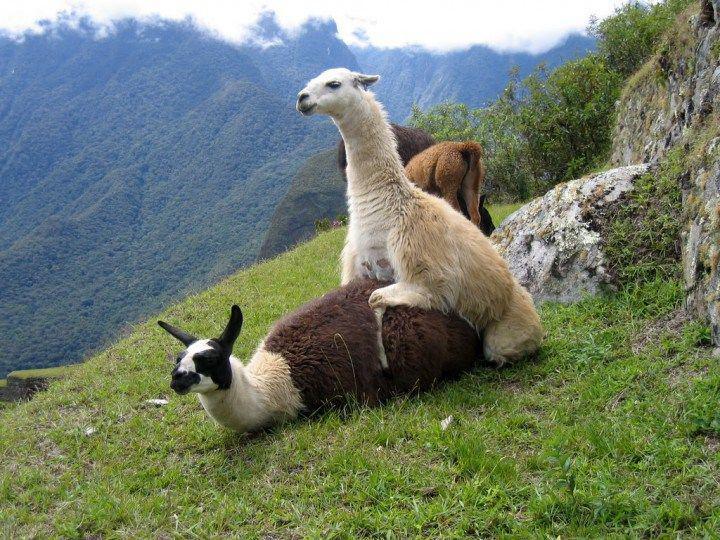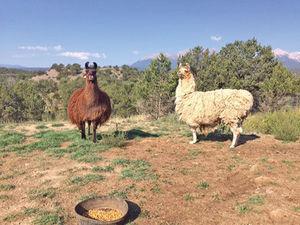The first image is the image on the left, the second image is the image on the right. Evaluate the accuracy of this statement regarding the images: "The llamas in the image on the right are standing with their sides touching.". Is it true? Answer yes or no. No. The first image is the image on the left, the second image is the image on the right. For the images shown, is this caption "There are llamas next to a wire fence." true? Answer yes or no. No. 